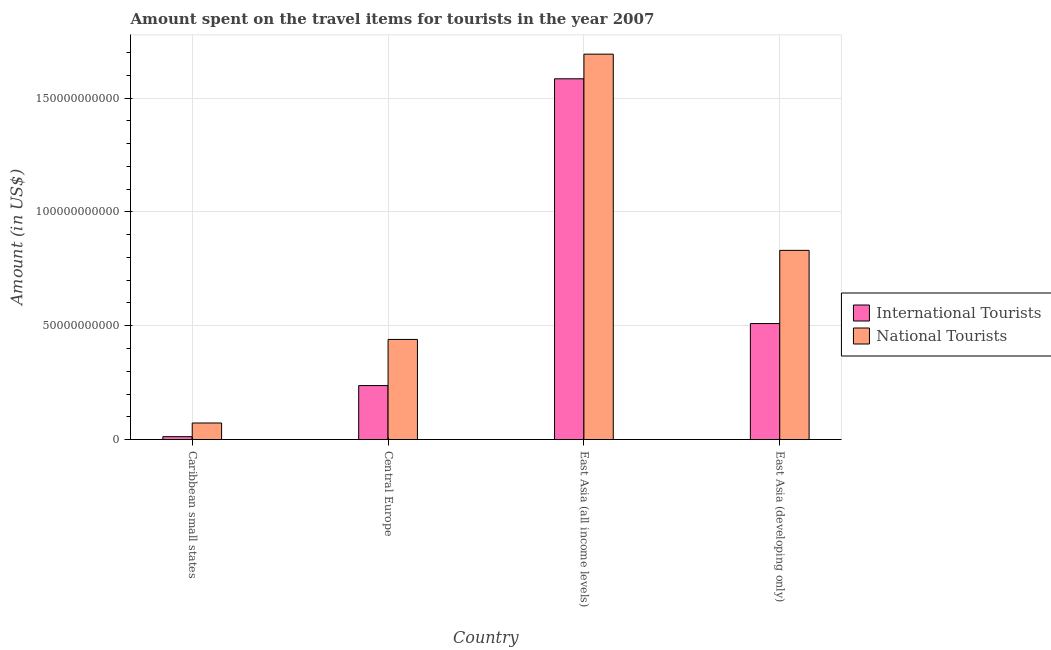How many different coloured bars are there?
Ensure brevity in your answer.  2. How many groups of bars are there?
Your answer should be compact. 4. Are the number of bars on each tick of the X-axis equal?
Make the answer very short. Yes. How many bars are there on the 4th tick from the left?
Make the answer very short. 2. What is the label of the 3rd group of bars from the left?
Ensure brevity in your answer.  East Asia (all income levels). In how many cases, is the number of bars for a given country not equal to the number of legend labels?
Your answer should be compact. 0. What is the amount spent on travel items of international tourists in Caribbean small states?
Make the answer very short. 1.26e+09. Across all countries, what is the maximum amount spent on travel items of international tourists?
Offer a very short reply. 1.59e+11. Across all countries, what is the minimum amount spent on travel items of national tourists?
Your answer should be very brief. 7.26e+09. In which country was the amount spent on travel items of international tourists maximum?
Ensure brevity in your answer.  East Asia (all income levels). In which country was the amount spent on travel items of international tourists minimum?
Your answer should be compact. Caribbean small states. What is the total amount spent on travel items of national tourists in the graph?
Your response must be concise. 3.04e+11. What is the difference between the amount spent on travel items of national tourists in Caribbean small states and that in Central Europe?
Your response must be concise. -3.67e+1. What is the difference between the amount spent on travel items of international tourists in East Asia (developing only) and the amount spent on travel items of national tourists in Central Europe?
Offer a terse response. 6.98e+09. What is the average amount spent on travel items of international tourists per country?
Provide a short and direct response. 5.86e+1. What is the difference between the amount spent on travel items of national tourists and amount spent on travel items of international tourists in Caribbean small states?
Ensure brevity in your answer.  6.00e+09. In how many countries, is the amount spent on travel items of international tourists greater than 40000000000 US$?
Make the answer very short. 2. What is the ratio of the amount spent on travel items of international tourists in Caribbean small states to that in East Asia (developing only)?
Your response must be concise. 0.02. Is the amount spent on travel items of national tourists in Caribbean small states less than that in Central Europe?
Provide a short and direct response. Yes. What is the difference between the highest and the second highest amount spent on travel items of international tourists?
Make the answer very short. 1.08e+11. What is the difference between the highest and the lowest amount spent on travel items of international tourists?
Provide a succinct answer. 1.57e+11. In how many countries, is the amount spent on travel items of national tourists greater than the average amount spent on travel items of national tourists taken over all countries?
Your answer should be compact. 2. Is the sum of the amount spent on travel items of international tourists in Caribbean small states and East Asia (developing only) greater than the maximum amount spent on travel items of national tourists across all countries?
Provide a succinct answer. No. What does the 1st bar from the left in East Asia (developing only) represents?
Offer a terse response. International Tourists. What does the 1st bar from the right in Central Europe represents?
Make the answer very short. National Tourists. How many bars are there?
Keep it short and to the point. 8. How many legend labels are there?
Your response must be concise. 2. What is the title of the graph?
Ensure brevity in your answer.  Amount spent on the travel items for tourists in the year 2007. What is the Amount (in US$) of International Tourists in Caribbean small states?
Provide a succinct answer. 1.26e+09. What is the Amount (in US$) of National Tourists in Caribbean small states?
Your response must be concise. 7.26e+09. What is the Amount (in US$) of International Tourists in Central Europe?
Provide a short and direct response. 2.37e+1. What is the Amount (in US$) in National Tourists in Central Europe?
Ensure brevity in your answer.  4.40e+1. What is the Amount (in US$) in International Tourists in East Asia (all income levels)?
Provide a succinct answer. 1.59e+11. What is the Amount (in US$) in National Tourists in East Asia (all income levels)?
Provide a short and direct response. 1.69e+11. What is the Amount (in US$) in International Tourists in East Asia (developing only)?
Keep it short and to the point. 5.10e+1. What is the Amount (in US$) in National Tourists in East Asia (developing only)?
Offer a very short reply. 8.31e+1. Across all countries, what is the maximum Amount (in US$) of International Tourists?
Your response must be concise. 1.59e+11. Across all countries, what is the maximum Amount (in US$) of National Tourists?
Give a very brief answer. 1.69e+11. Across all countries, what is the minimum Amount (in US$) in International Tourists?
Your answer should be compact. 1.26e+09. Across all countries, what is the minimum Amount (in US$) in National Tourists?
Offer a very short reply. 7.26e+09. What is the total Amount (in US$) of International Tourists in the graph?
Your answer should be compact. 2.34e+11. What is the total Amount (in US$) in National Tourists in the graph?
Your answer should be compact. 3.04e+11. What is the difference between the Amount (in US$) in International Tourists in Caribbean small states and that in Central Europe?
Provide a succinct answer. -2.24e+1. What is the difference between the Amount (in US$) in National Tourists in Caribbean small states and that in Central Europe?
Provide a short and direct response. -3.67e+1. What is the difference between the Amount (in US$) of International Tourists in Caribbean small states and that in East Asia (all income levels)?
Ensure brevity in your answer.  -1.57e+11. What is the difference between the Amount (in US$) in National Tourists in Caribbean small states and that in East Asia (all income levels)?
Your response must be concise. -1.62e+11. What is the difference between the Amount (in US$) of International Tourists in Caribbean small states and that in East Asia (developing only)?
Give a very brief answer. -4.97e+1. What is the difference between the Amount (in US$) in National Tourists in Caribbean small states and that in East Asia (developing only)?
Your answer should be very brief. -7.59e+1. What is the difference between the Amount (in US$) of International Tourists in Central Europe and that in East Asia (all income levels)?
Provide a short and direct response. -1.35e+11. What is the difference between the Amount (in US$) of National Tourists in Central Europe and that in East Asia (all income levels)?
Make the answer very short. -1.25e+11. What is the difference between the Amount (in US$) in International Tourists in Central Europe and that in East Asia (developing only)?
Keep it short and to the point. -2.73e+1. What is the difference between the Amount (in US$) of National Tourists in Central Europe and that in East Asia (developing only)?
Keep it short and to the point. -3.91e+1. What is the difference between the Amount (in US$) in International Tourists in East Asia (all income levels) and that in East Asia (developing only)?
Make the answer very short. 1.08e+11. What is the difference between the Amount (in US$) of National Tourists in East Asia (all income levels) and that in East Asia (developing only)?
Give a very brief answer. 8.62e+1. What is the difference between the Amount (in US$) in International Tourists in Caribbean small states and the Amount (in US$) in National Tourists in Central Europe?
Offer a terse response. -4.27e+1. What is the difference between the Amount (in US$) in International Tourists in Caribbean small states and the Amount (in US$) in National Tourists in East Asia (all income levels)?
Your response must be concise. -1.68e+11. What is the difference between the Amount (in US$) in International Tourists in Caribbean small states and the Amount (in US$) in National Tourists in East Asia (developing only)?
Your answer should be compact. -8.19e+1. What is the difference between the Amount (in US$) in International Tourists in Central Europe and the Amount (in US$) in National Tourists in East Asia (all income levels)?
Provide a succinct answer. -1.46e+11. What is the difference between the Amount (in US$) in International Tourists in Central Europe and the Amount (in US$) in National Tourists in East Asia (developing only)?
Give a very brief answer. -5.94e+1. What is the difference between the Amount (in US$) of International Tourists in East Asia (all income levels) and the Amount (in US$) of National Tourists in East Asia (developing only)?
Ensure brevity in your answer.  7.54e+1. What is the average Amount (in US$) in International Tourists per country?
Make the answer very short. 5.86e+1. What is the average Amount (in US$) in National Tourists per country?
Your answer should be compact. 7.59e+1. What is the difference between the Amount (in US$) in International Tourists and Amount (in US$) in National Tourists in Caribbean small states?
Ensure brevity in your answer.  -6.00e+09. What is the difference between the Amount (in US$) in International Tourists and Amount (in US$) in National Tourists in Central Europe?
Offer a very short reply. -2.03e+1. What is the difference between the Amount (in US$) in International Tourists and Amount (in US$) in National Tourists in East Asia (all income levels)?
Offer a terse response. -1.08e+1. What is the difference between the Amount (in US$) in International Tourists and Amount (in US$) in National Tourists in East Asia (developing only)?
Keep it short and to the point. -3.22e+1. What is the ratio of the Amount (in US$) in International Tourists in Caribbean small states to that in Central Europe?
Offer a very short reply. 0.05. What is the ratio of the Amount (in US$) of National Tourists in Caribbean small states to that in Central Europe?
Make the answer very short. 0.17. What is the ratio of the Amount (in US$) in International Tourists in Caribbean small states to that in East Asia (all income levels)?
Provide a succinct answer. 0.01. What is the ratio of the Amount (in US$) of National Tourists in Caribbean small states to that in East Asia (all income levels)?
Your answer should be very brief. 0.04. What is the ratio of the Amount (in US$) of International Tourists in Caribbean small states to that in East Asia (developing only)?
Make the answer very short. 0.02. What is the ratio of the Amount (in US$) of National Tourists in Caribbean small states to that in East Asia (developing only)?
Ensure brevity in your answer.  0.09. What is the ratio of the Amount (in US$) in International Tourists in Central Europe to that in East Asia (all income levels)?
Your response must be concise. 0.15. What is the ratio of the Amount (in US$) of National Tourists in Central Europe to that in East Asia (all income levels)?
Provide a short and direct response. 0.26. What is the ratio of the Amount (in US$) in International Tourists in Central Europe to that in East Asia (developing only)?
Your answer should be very brief. 0.47. What is the ratio of the Amount (in US$) in National Tourists in Central Europe to that in East Asia (developing only)?
Offer a terse response. 0.53. What is the ratio of the Amount (in US$) in International Tourists in East Asia (all income levels) to that in East Asia (developing only)?
Provide a short and direct response. 3.11. What is the ratio of the Amount (in US$) in National Tourists in East Asia (all income levels) to that in East Asia (developing only)?
Offer a terse response. 2.04. What is the difference between the highest and the second highest Amount (in US$) in International Tourists?
Your answer should be very brief. 1.08e+11. What is the difference between the highest and the second highest Amount (in US$) of National Tourists?
Offer a terse response. 8.62e+1. What is the difference between the highest and the lowest Amount (in US$) of International Tourists?
Offer a very short reply. 1.57e+11. What is the difference between the highest and the lowest Amount (in US$) in National Tourists?
Offer a terse response. 1.62e+11. 